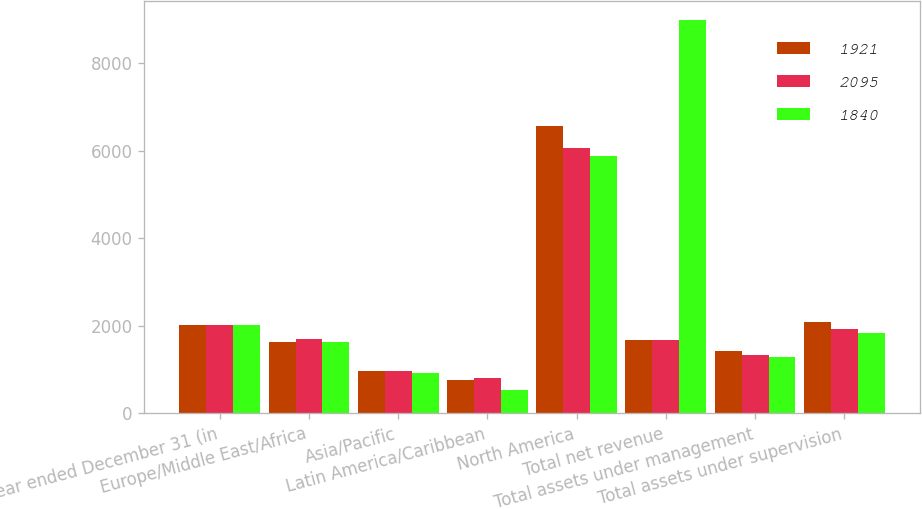Convert chart. <chart><loc_0><loc_0><loc_500><loc_500><stacked_bar_chart><ecel><fcel>Year ended December 31 (in<fcel>Europe/Middle East/Africa<fcel>Asia/Pacific<fcel>Latin America/Caribbean<fcel>North America<fcel>Total net revenue<fcel>Total assets under management<fcel>Total assets under supervision<nl><fcel>1921<fcel>2012<fcel>1641<fcel>967<fcel>772<fcel>6566<fcel>1673<fcel>1426<fcel>2095<nl><fcel>2095<fcel>2011<fcel>1704<fcel>971<fcel>808<fcel>6060<fcel>1673<fcel>1336<fcel>1921<nl><fcel>1840<fcel>2010<fcel>1642<fcel>925<fcel>541<fcel>5876<fcel>8984<fcel>1298<fcel>1840<nl></chart> 